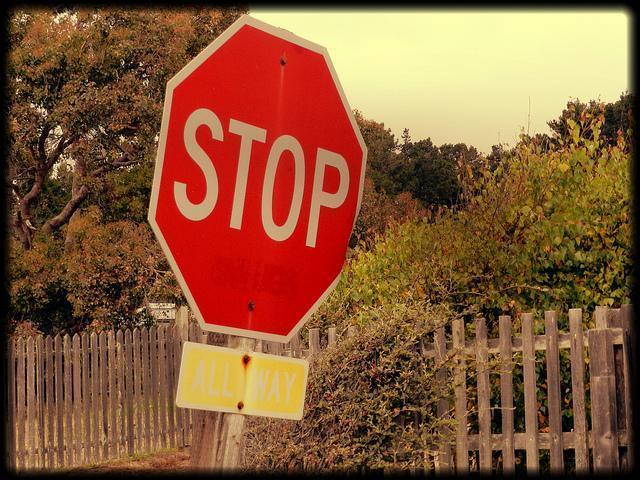How many people are skateboarding across cone?
Give a very brief answer. 0. 